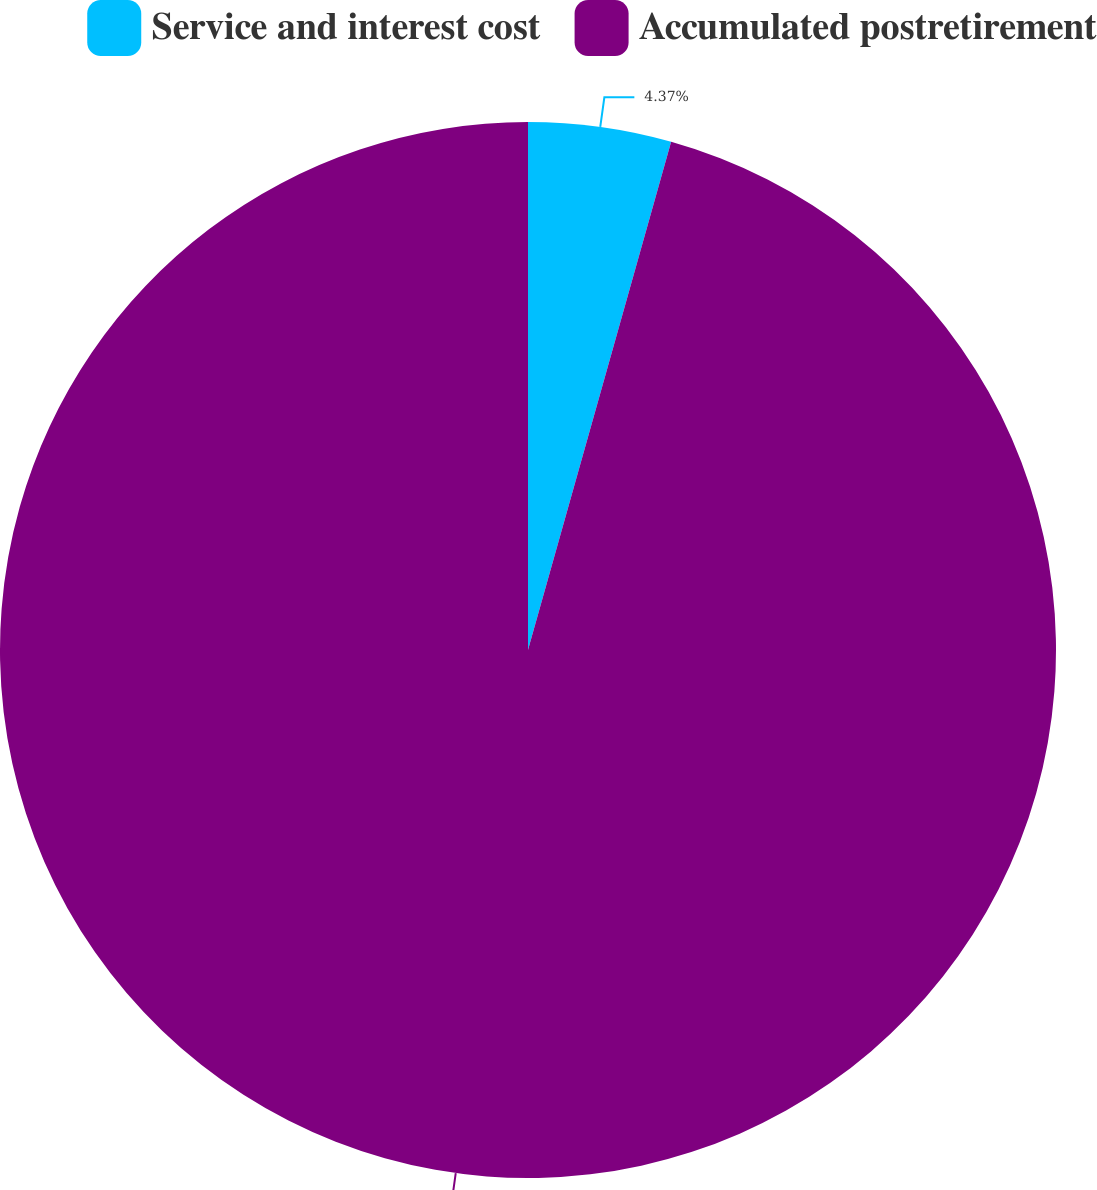Convert chart. <chart><loc_0><loc_0><loc_500><loc_500><pie_chart><fcel>Service and interest cost<fcel>Accumulated postretirement<nl><fcel>4.37%<fcel>95.63%<nl></chart> 